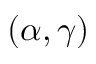Convert formula to latex. <formula><loc_0><loc_0><loc_500><loc_500>( \alpha , \gamma )</formula> 